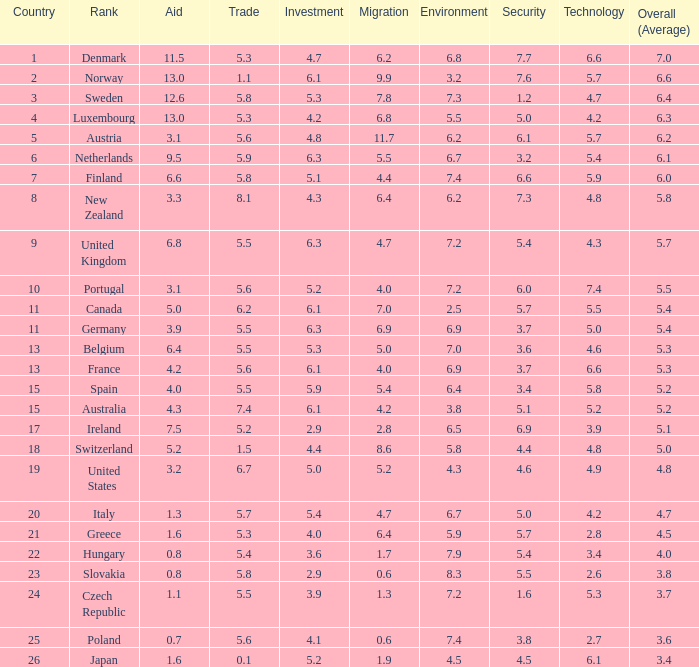How many times is denmark ranked in technology? 1.0. 